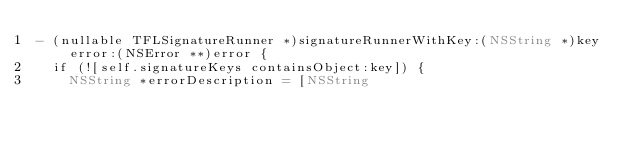Convert code to text. <code><loc_0><loc_0><loc_500><loc_500><_ObjectiveC_>- (nullable TFLSignatureRunner *)signatureRunnerWithKey:(NSString *)key error:(NSError **)error {
  if (![self.signatureKeys containsObject:key]) {
    NSString *errorDescription = [NSString</code> 